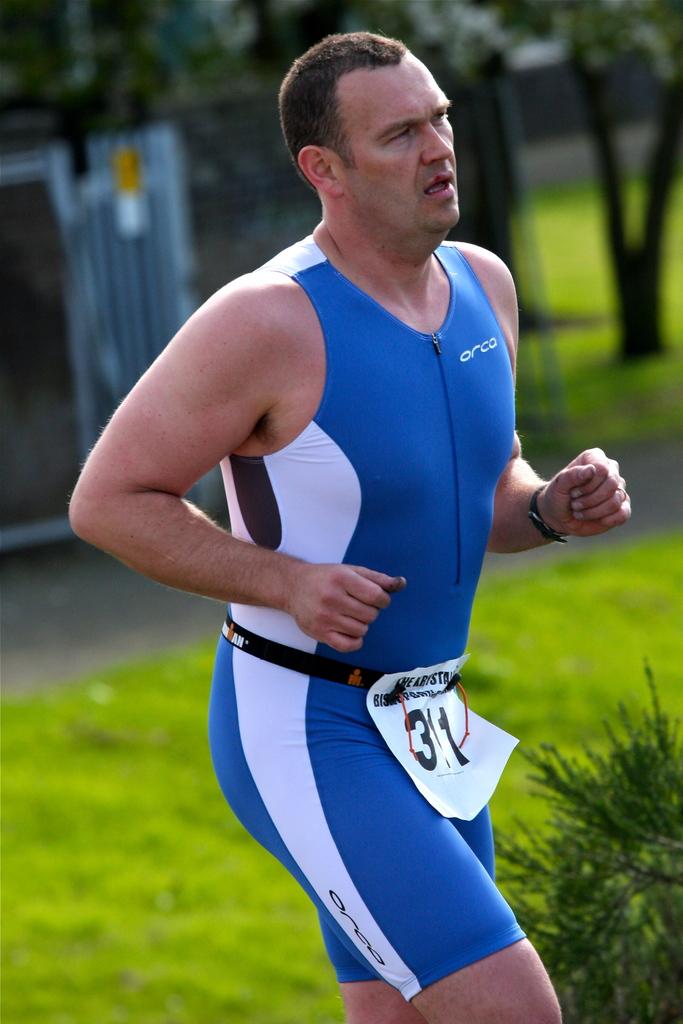What brand is his suit?
Keep it short and to the point. Orca. What number is he?
Make the answer very short. 31. 